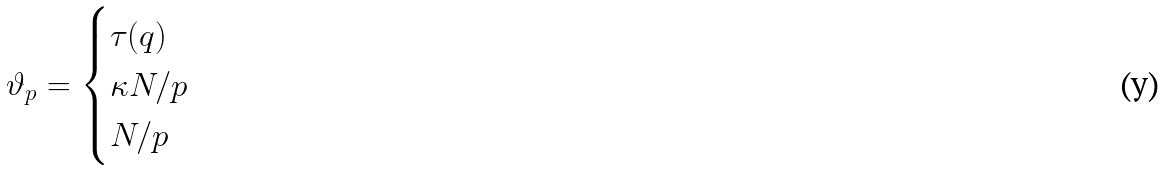Convert formula to latex. <formula><loc_0><loc_0><loc_500><loc_500>\vartheta _ { p } = \begin{cases} \tau ( q ) & \\ \kappa N / p & \\ N / p & \end{cases}</formula> 